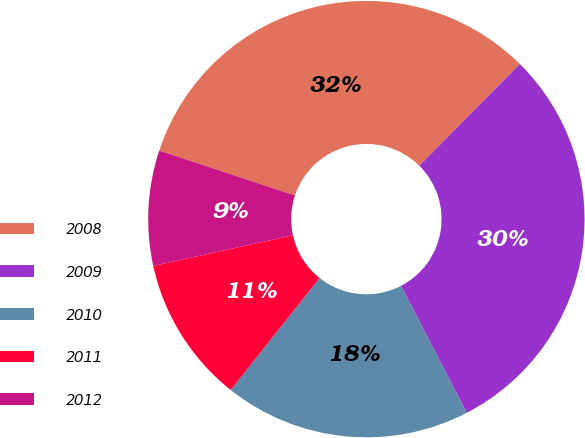<chart> <loc_0><loc_0><loc_500><loc_500><pie_chart><fcel>2008<fcel>2009<fcel>2010<fcel>2011<fcel>2012<nl><fcel>32.33%<fcel>29.98%<fcel>18.29%<fcel>10.88%<fcel>8.53%<nl></chart> 